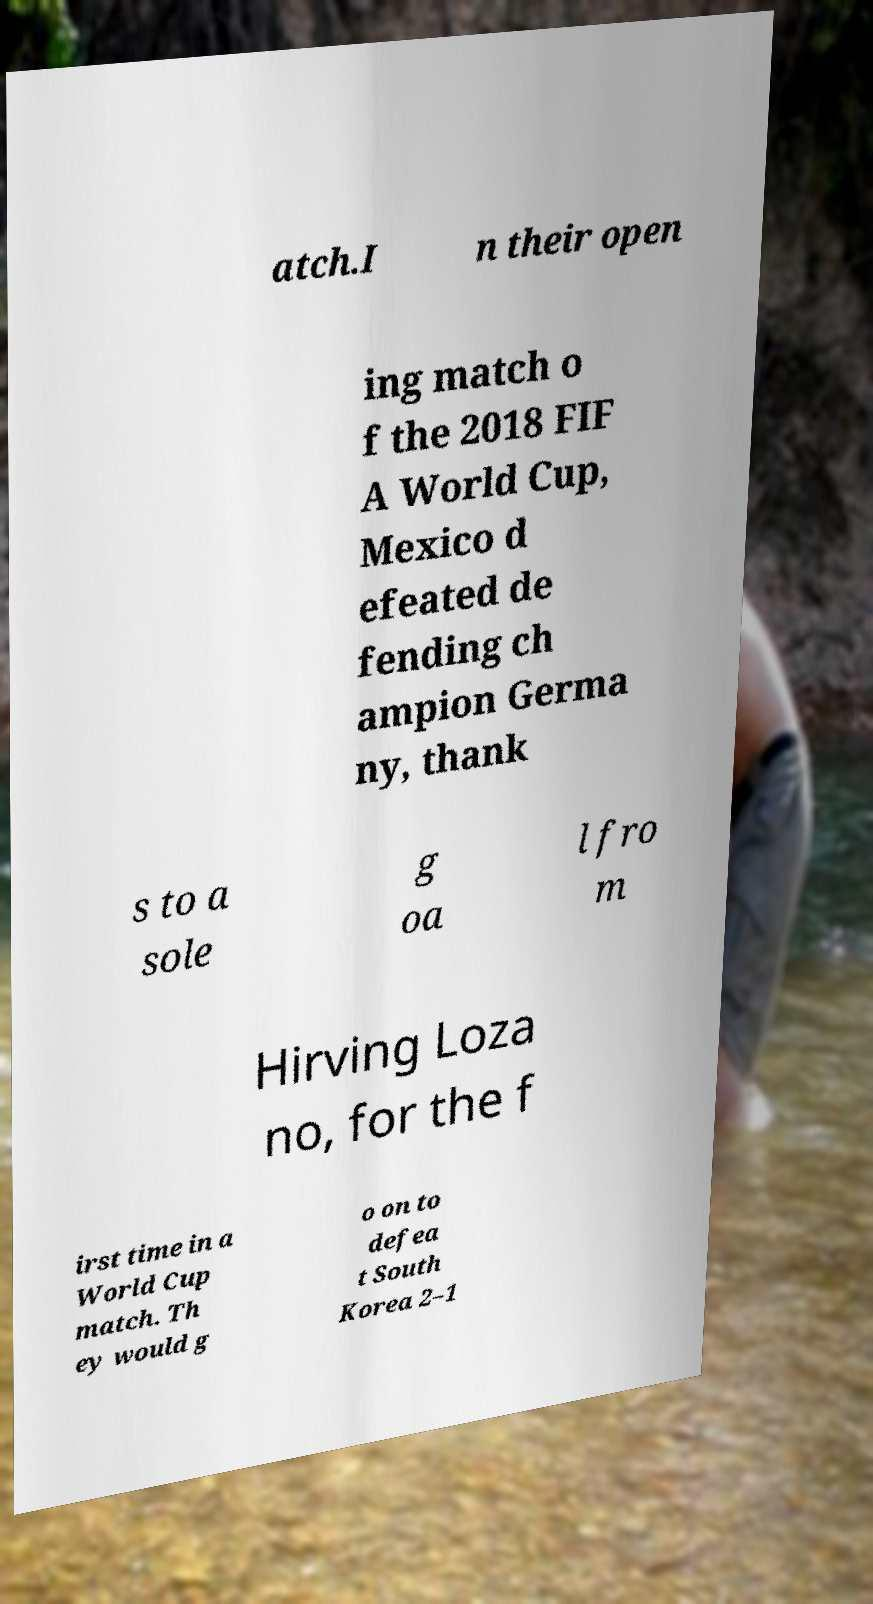Could you assist in decoding the text presented in this image and type it out clearly? atch.I n their open ing match o f the 2018 FIF A World Cup, Mexico d efeated de fending ch ampion Germa ny, thank s to a sole g oa l fro m Hirving Loza no, for the f irst time in a World Cup match. Th ey would g o on to defea t South Korea 2–1 